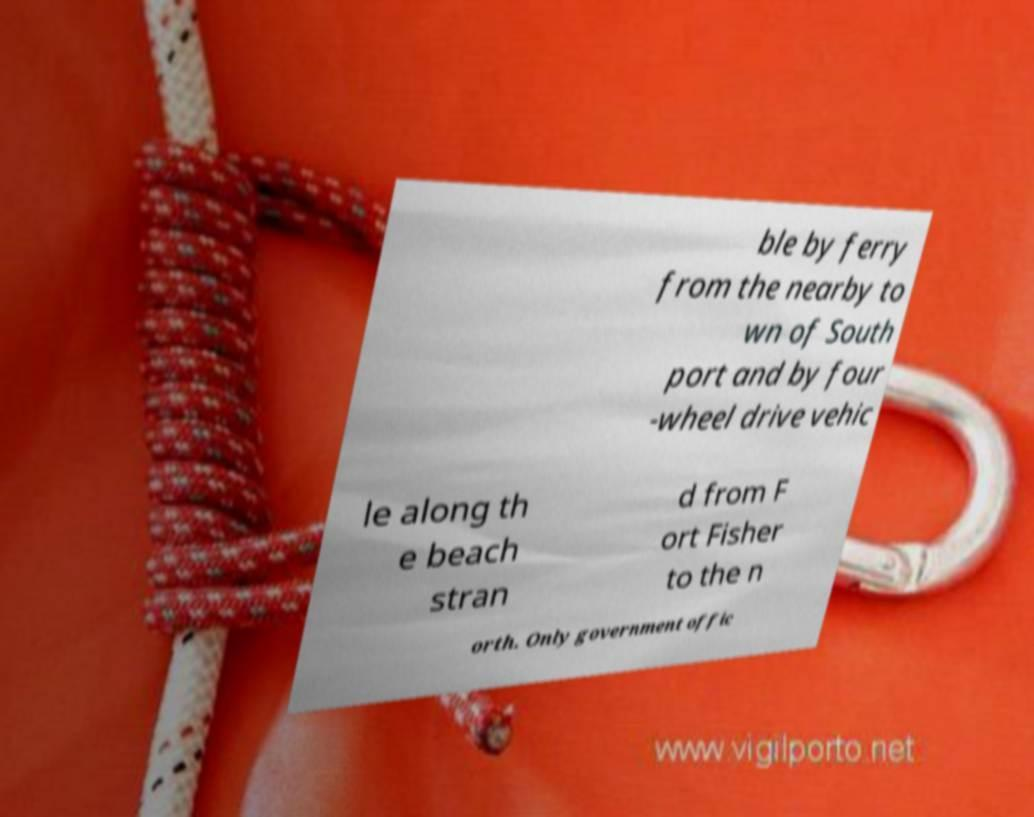Can you accurately transcribe the text from the provided image for me? ble by ferry from the nearby to wn of South port and by four -wheel drive vehic le along th e beach stran d from F ort Fisher to the n orth. Only government offic 